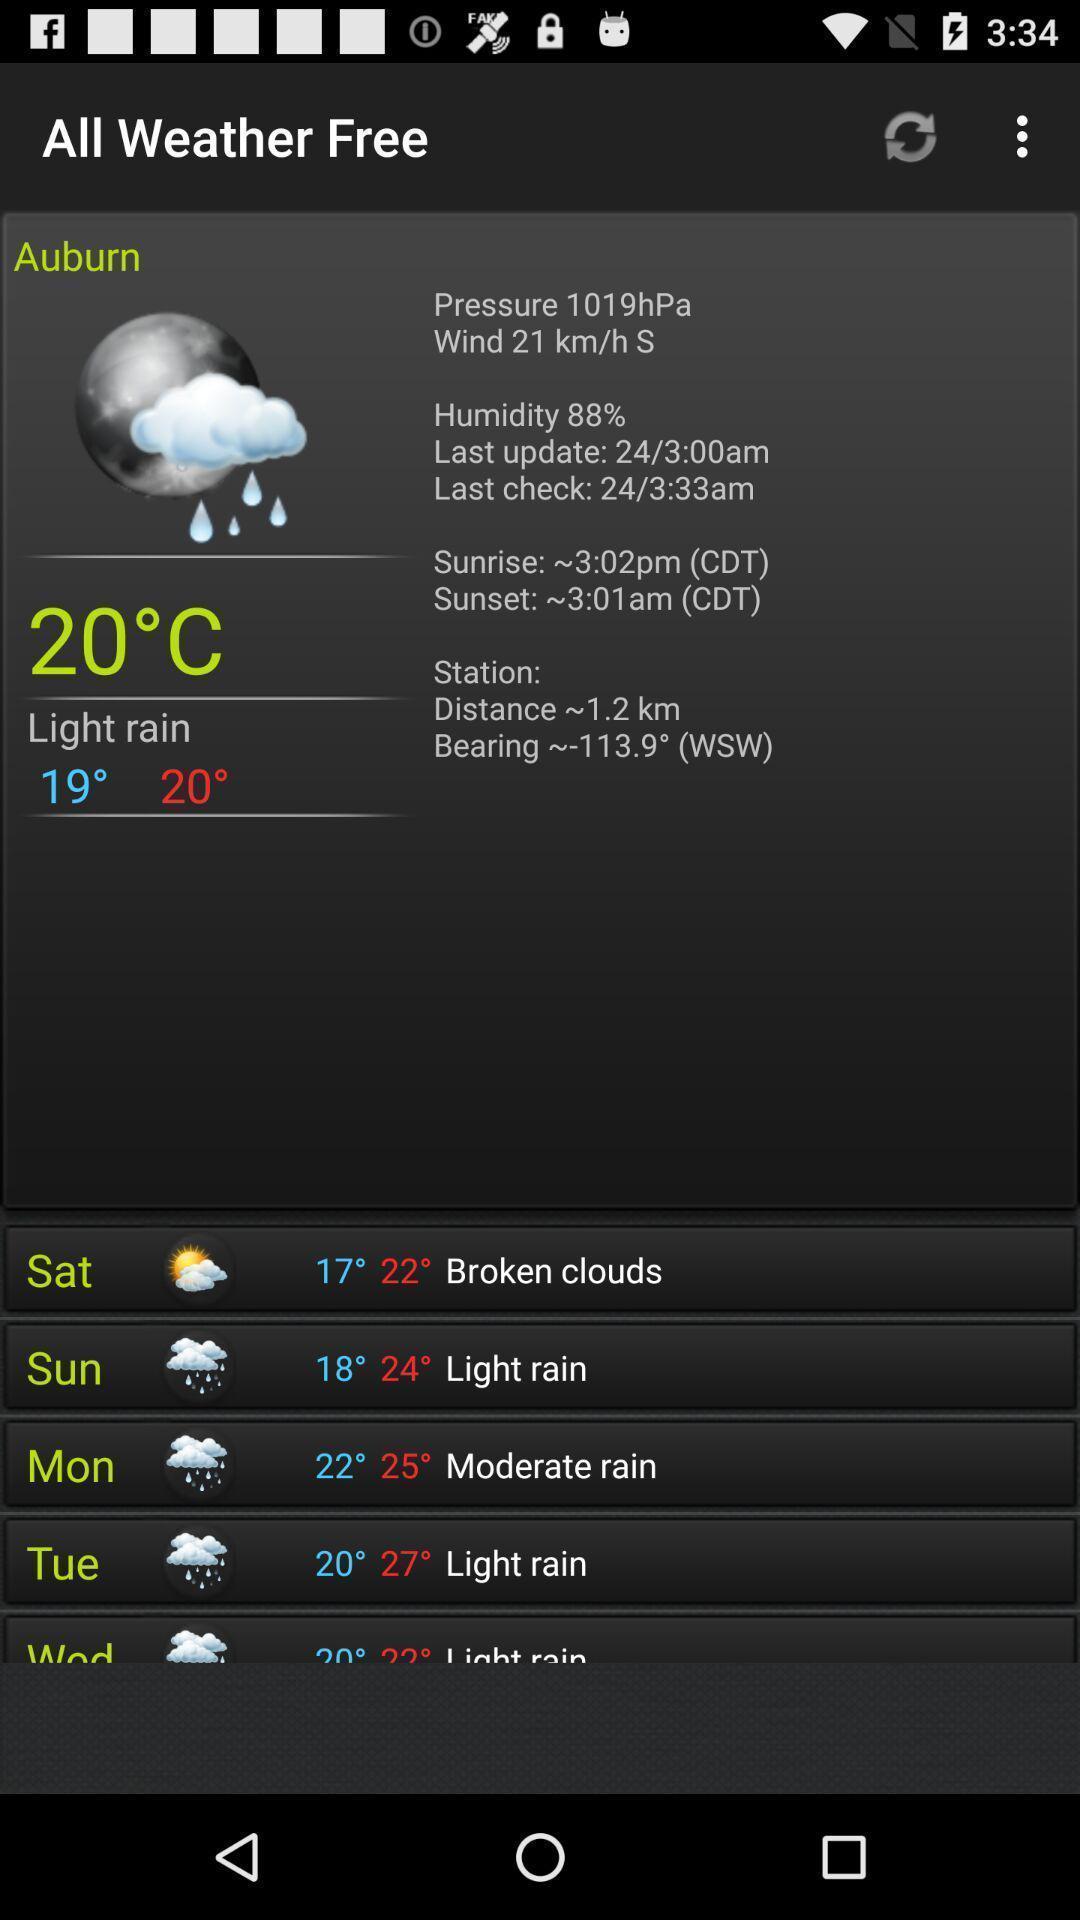Tell me about the visual elements in this screen capture. Page displaying weather stats in weather forecasting app. 